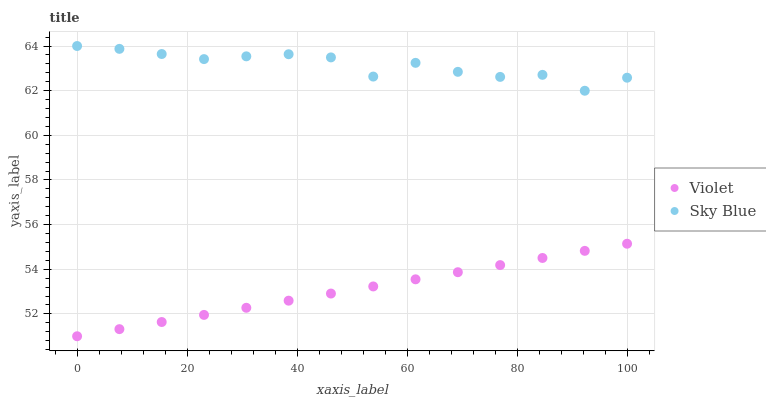Does Violet have the minimum area under the curve?
Answer yes or no. Yes. Does Sky Blue have the maximum area under the curve?
Answer yes or no. Yes. Does Violet have the maximum area under the curve?
Answer yes or no. No. Is Violet the smoothest?
Answer yes or no. Yes. Is Sky Blue the roughest?
Answer yes or no. Yes. Is Violet the roughest?
Answer yes or no. No. Does Violet have the lowest value?
Answer yes or no. Yes. Does Sky Blue have the highest value?
Answer yes or no. Yes. Does Violet have the highest value?
Answer yes or no. No. Is Violet less than Sky Blue?
Answer yes or no. Yes. Is Sky Blue greater than Violet?
Answer yes or no. Yes. Does Violet intersect Sky Blue?
Answer yes or no. No. 